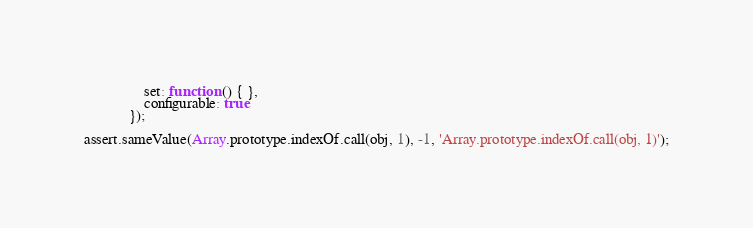<code> <loc_0><loc_0><loc_500><loc_500><_JavaScript_>                set: function () { },
                configurable: true
            });

assert.sameValue(Array.prototype.indexOf.call(obj, 1), -1, 'Array.prototype.indexOf.call(obj, 1)');
</code> 